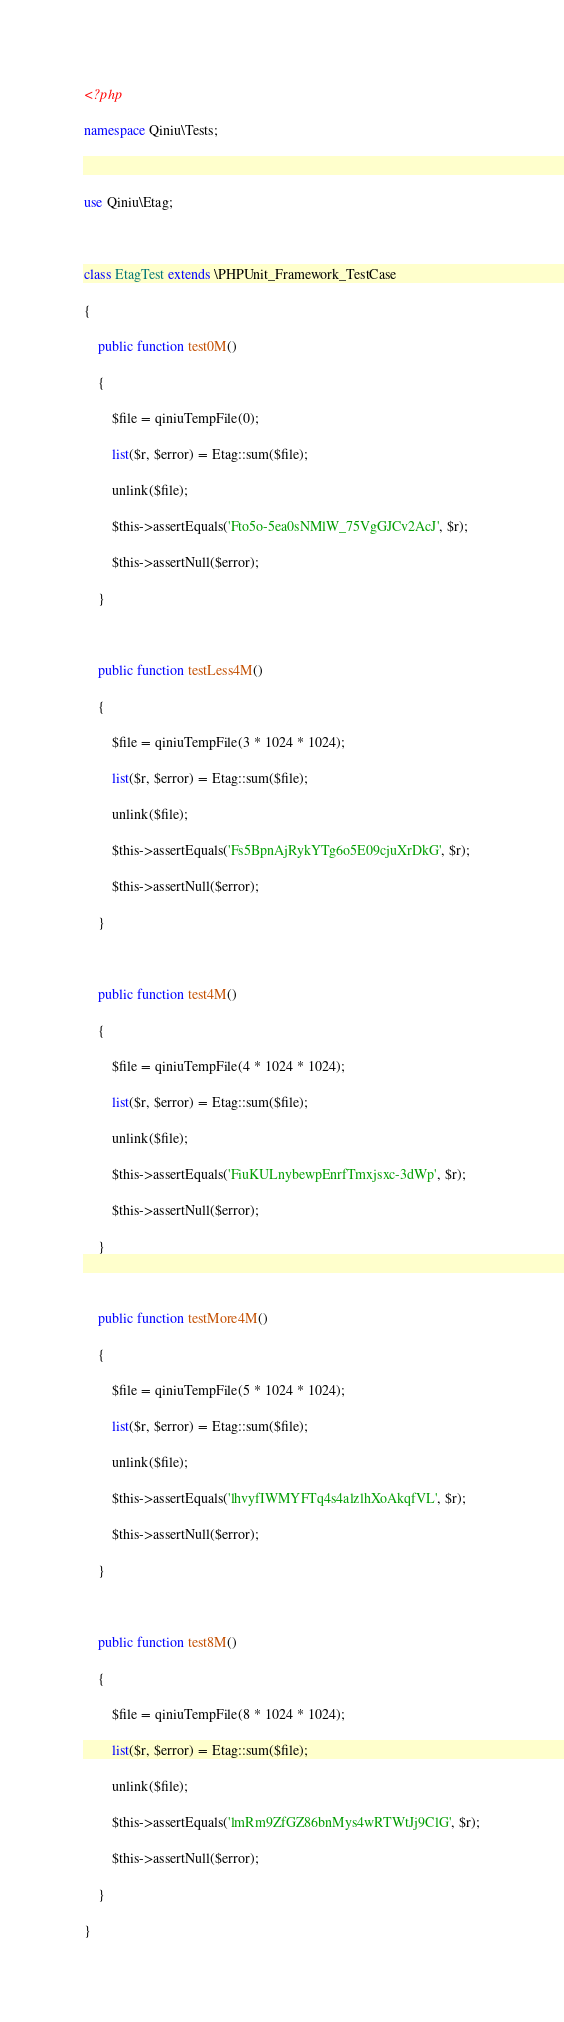Convert code to text. <code><loc_0><loc_0><loc_500><loc_500><_PHP_><?php
namespace Qiniu\Tests;

use Qiniu\Etag;

class EtagTest extends \PHPUnit_Framework_TestCase
{
    public function test0M()
    {
        $file = qiniuTempFile(0);
        list($r, $error) = Etag::sum($file);
        unlink($file);
        $this->assertEquals('Fto5o-5ea0sNMlW_75VgGJCv2AcJ', $r);
        $this->assertNull($error);
    }

    public function testLess4M()
    {
        $file = qiniuTempFile(3 * 1024 * 1024);
        list($r, $error) = Etag::sum($file);
        unlink($file);
        $this->assertEquals('Fs5BpnAjRykYTg6o5E09cjuXrDkG', $r);
        $this->assertNull($error);
    }

    public function test4M()
    {
        $file = qiniuTempFile(4 * 1024 * 1024);
        list($r, $error) = Etag::sum($file);
        unlink($file);
        $this->assertEquals('FiuKULnybewpEnrfTmxjsxc-3dWp', $r);
        $this->assertNull($error);
    }

    public function testMore4M()
    {
        $file = qiniuTempFile(5 * 1024 * 1024);
        list($r, $error) = Etag::sum($file);
        unlink($file);
        $this->assertEquals('lhvyfIWMYFTq4s4alzlhXoAkqfVL', $r);
        $this->assertNull($error);
    }

    public function test8M()
    {
        $file = qiniuTempFile(8 * 1024 * 1024);
        list($r, $error) = Etag::sum($file);
        unlink($file);
        $this->assertEquals('lmRm9ZfGZ86bnMys4wRTWtJj9ClG', $r);
        $this->assertNull($error);
    }
}
</code> 